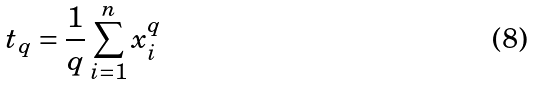Convert formula to latex. <formula><loc_0><loc_0><loc_500><loc_500>t _ { q } = \frac { 1 } { q } \sum _ { i = 1 } ^ { n } x _ { i } ^ { q }</formula> 